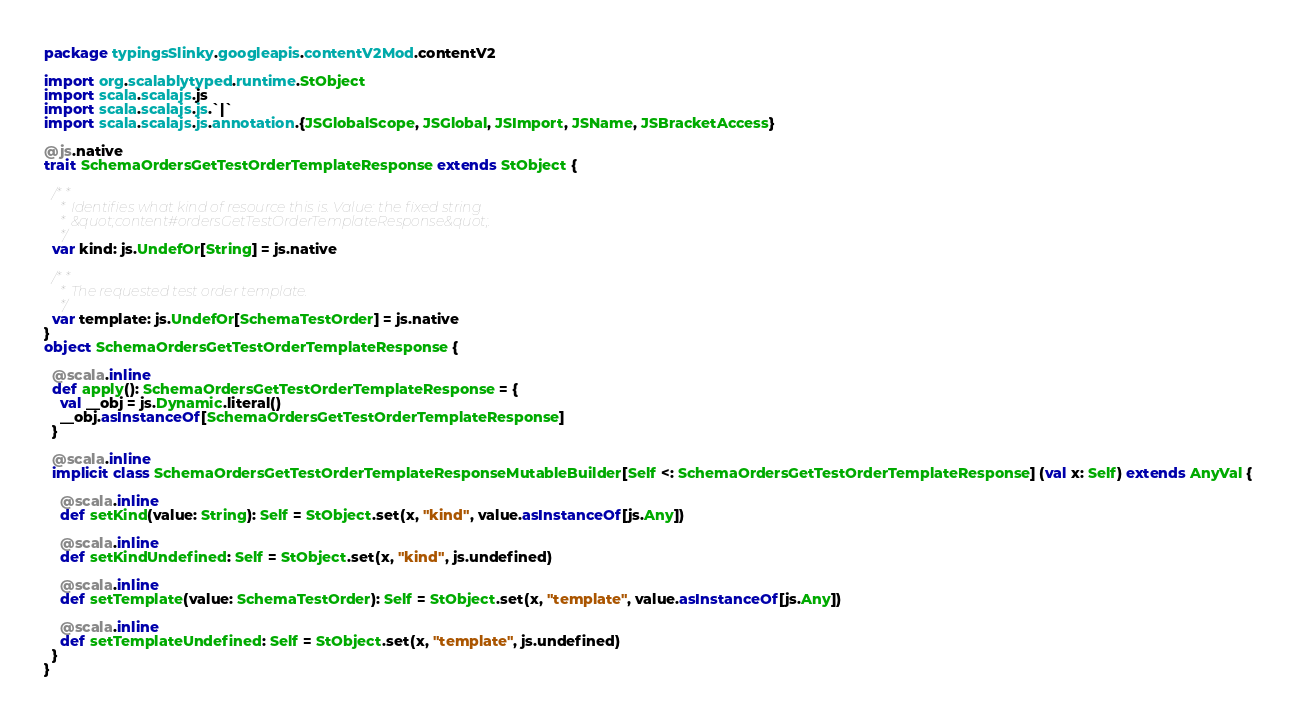<code> <loc_0><loc_0><loc_500><loc_500><_Scala_>package typingsSlinky.googleapis.contentV2Mod.contentV2

import org.scalablytyped.runtime.StObject
import scala.scalajs.js
import scala.scalajs.js.`|`
import scala.scalajs.js.annotation.{JSGlobalScope, JSGlobal, JSImport, JSName, JSBracketAccess}

@js.native
trait SchemaOrdersGetTestOrderTemplateResponse extends StObject {
  
  /**
    * Identifies what kind of resource this is. Value: the fixed string
    * &quot;content#ordersGetTestOrderTemplateResponse&quot;.
    */
  var kind: js.UndefOr[String] = js.native
  
  /**
    * The requested test order template.
    */
  var template: js.UndefOr[SchemaTestOrder] = js.native
}
object SchemaOrdersGetTestOrderTemplateResponse {
  
  @scala.inline
  def apply(): SchemaOrdersGetTestOrderTemplateResponse = {
    val __obj = js.Dynamic.literal()
    __obj.asInstanceOf[SchemaOrdersGetTestOrderTemplateResponse]
  }
  
  @scala.inline
  implicit class SchemaOrdersGetTestOrderTemplateResponseMutableBuilder[Self <: SchemaOrdersGetTestOrderTemplateResponse] (val x: Self) extends AnyVal {
    
    @scala.inline
    def setKind(value: String): Self = StObject.set(x, "kind", value.asInstanceOf[js.Any])
    
    @scala.inline
    def setKindUndefined: Self = StObject.set(x, "kind", js.undefined)
    
    @scala.inline
    def setTemplate(value: SchemaTestOrder): Self = StObject.set(x, "template", value.asInstanceOf[js.Any])
    
    @scala.inline
    def setTemplateUndefined: Self = StObject.set(x, "template", js.undefined)
  }
}
</code> 